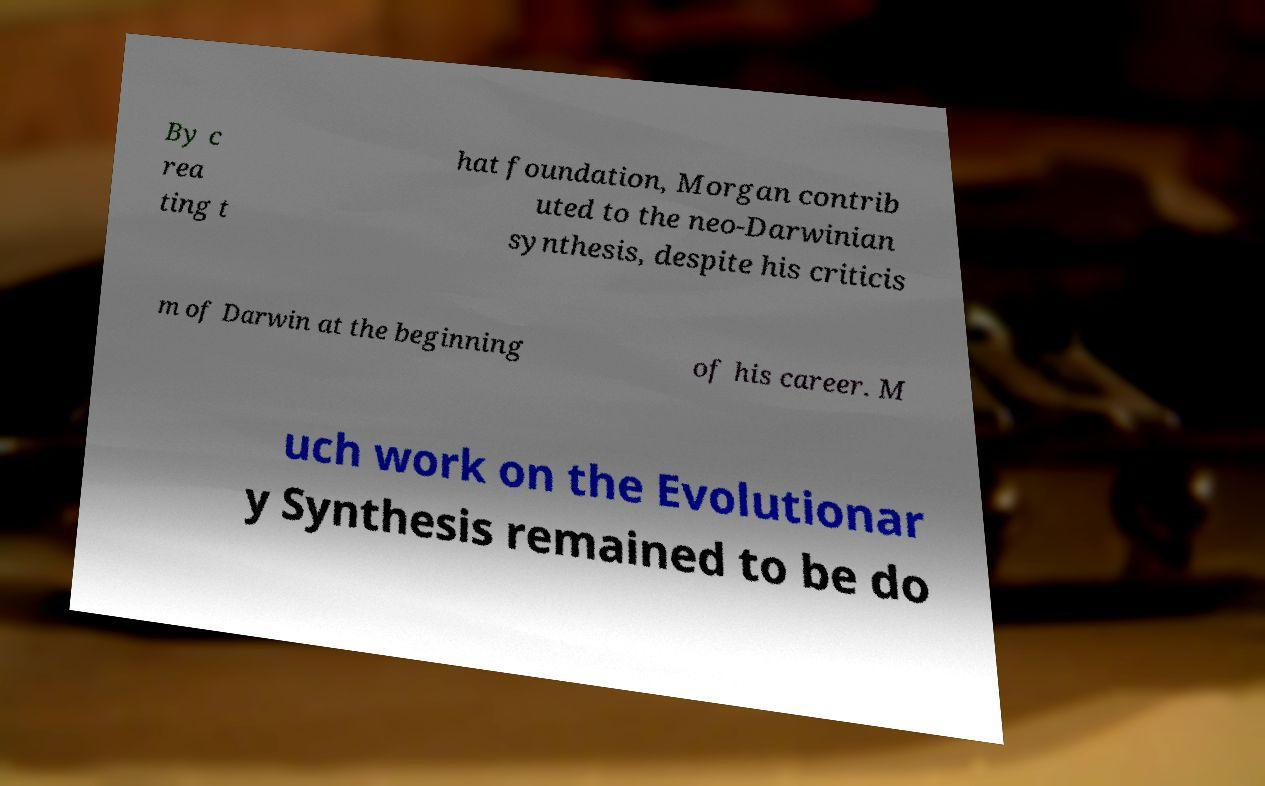Can you read and provide the text displayed in the image?This photo seems to have some interesting text. Can you extract and type it out for me? By c rea ting t hat foundation, Morgan contrib uted to the neo-Darwinian synthesis, despite his criticis m of Darwin at the beginning of his career. M uch work on the Evolutionar y Synthesis remained to be do 